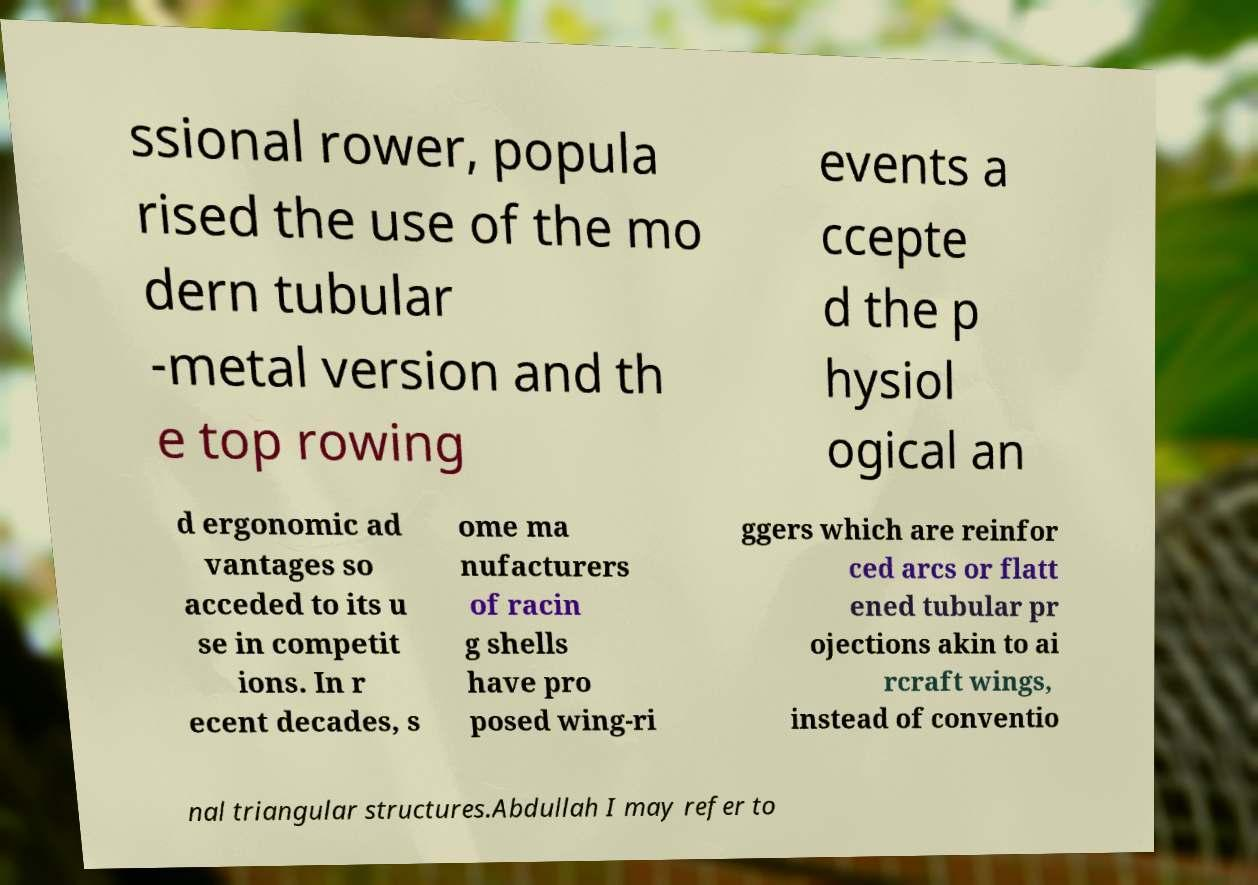I need the written content from this picture converted into text. Can you do that? ssional rower, popula rised the use of the mo dern tubular -metal version and th e top rowing events a ccepte d the p hysiol ogical an d ergonomic ad vantages so acceded to its u se in competit ions. In r ecent decades, s ome ma nufacturers of racin g shells have pro posed wing-ri ggers which are reinfor ced arcs or flatt ened tubular pr ojections akin to ai rcraft wings, instead of conventio nal triangular structures.Abdullah I may refer to 